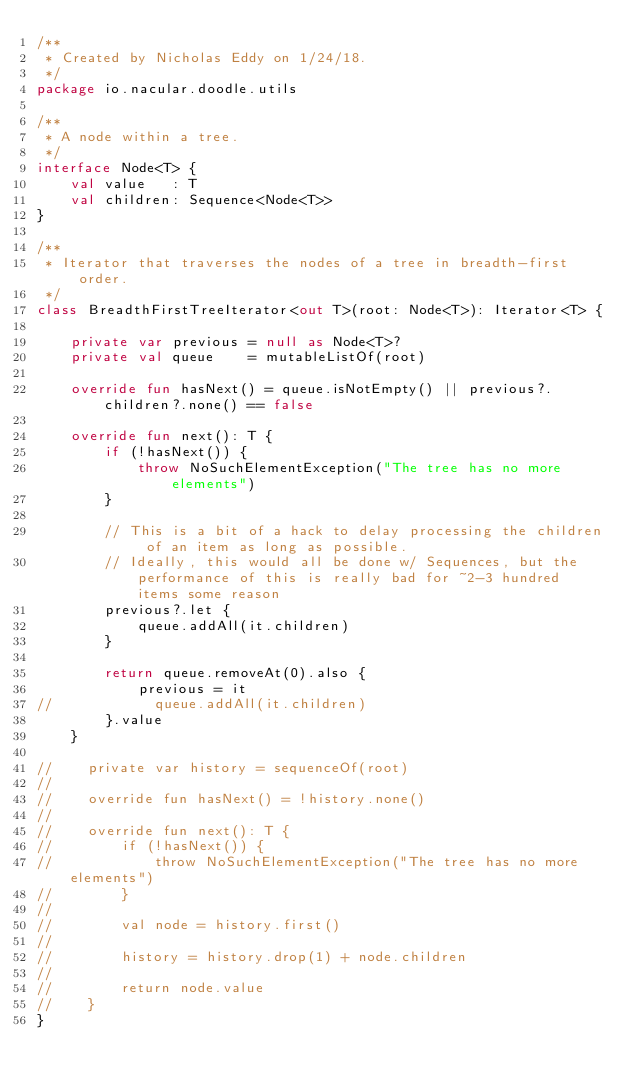Convert code to text. <code><loc_0><loc_0><loc_500><loc_500><_Kotlin_>/**
 * Created by Nicholas Eddy on 1/24/18.
 */
package io.nacular.doodle.utils

/**
 * A node within a tree.
 */
interface Node<T> {
    val value   : T
    val children: Sequence<Node<T>>
}

/**
 * Iterator that traverses the nodes of a tree in breadth-first order.
 */
class BreadthFirstTreeIterator<out T>(root: Node<T>): Iterator<T> {

    private var previous = null as Node<T>?
    private val queue    = mutableListOf(root)

    override fun hasNext() = queue.isNotEmpty() || previous?.children?.none() == false

    override fun next(): T {
        if (!hasNext()) {
            throw NoSuchElementException("The tree has no more elements")
        }

        // This is a bit of a hack to delay processing the children of an item as long as possible.
        // Ideally, this would all be done w/ Sequences, but the performance of this is really bad for ~2-3 hundred items some reason
        previous?.let {
            queue.addAll(it.children)
        }

        return queue.removeAt(0).also {
            previous = it
//            queue.addAll(it.children)
        }.value
    }

//    private var history = sequenceOf(root)
//
//    override fun hasNext() = !history.none()
//
//    override fun next(): T {
//        if (!hasNext()) {
//            throw NoSuchElementException("The tree has no more elements")
//        }
//
//        val node = history.first()
//
//        history = history.drop(1) + node.children
//
//        return node.value
//    }
}</code> 